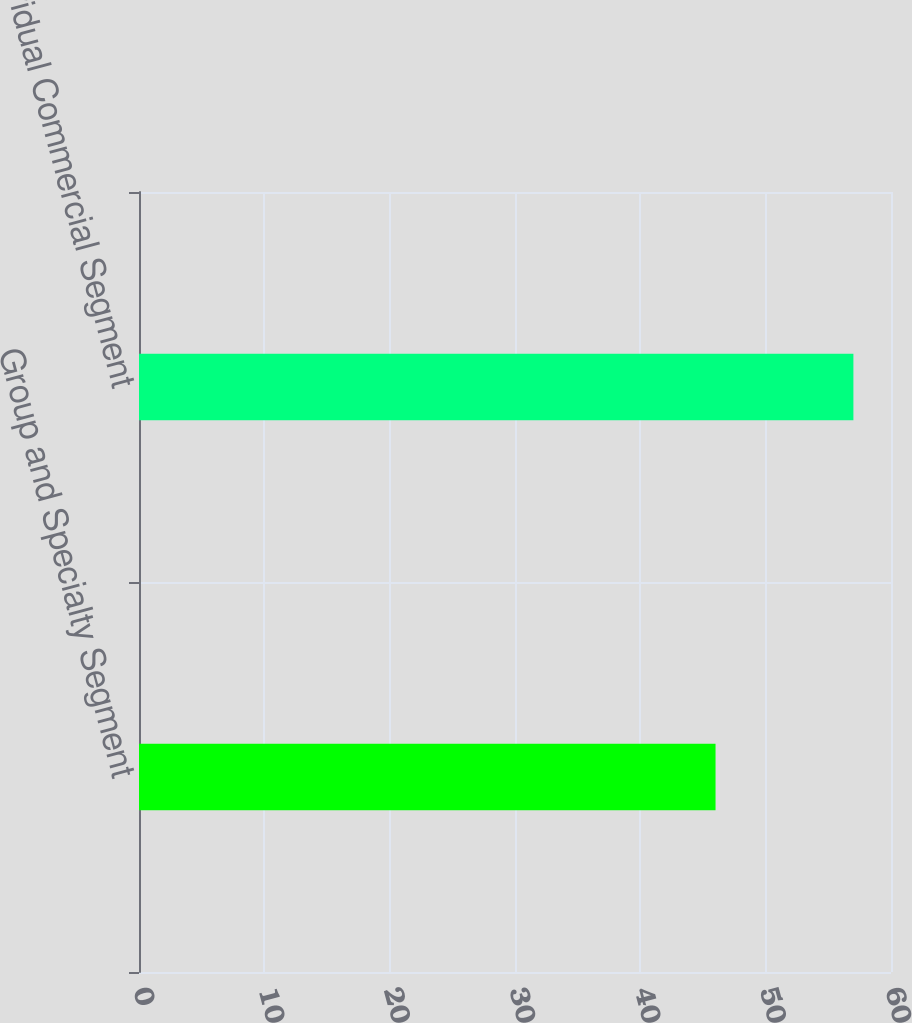Convert chart to OTSL. <chart><loc_0><loc_0><loc_500><loc_500><bar_chart><fcel>Group and Specialty Segment<fcel>Individual Commercial Segment<nl><fcel>46<fcel>57<nl></chart> 